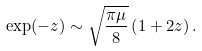Convert formula to latex. <formula><loc_0><loc_0><loc_500><loc_500>\exp ( - z ) \sim \sqrt { \frac { \pi \mu } { 8 } } \left ( 1 + 2 z \right ) .</formula> 